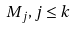Convert formula to latex. <formula><loc_0><loc_0><loc_500><loc_500>M _ { j } , j \leq k</formula> 